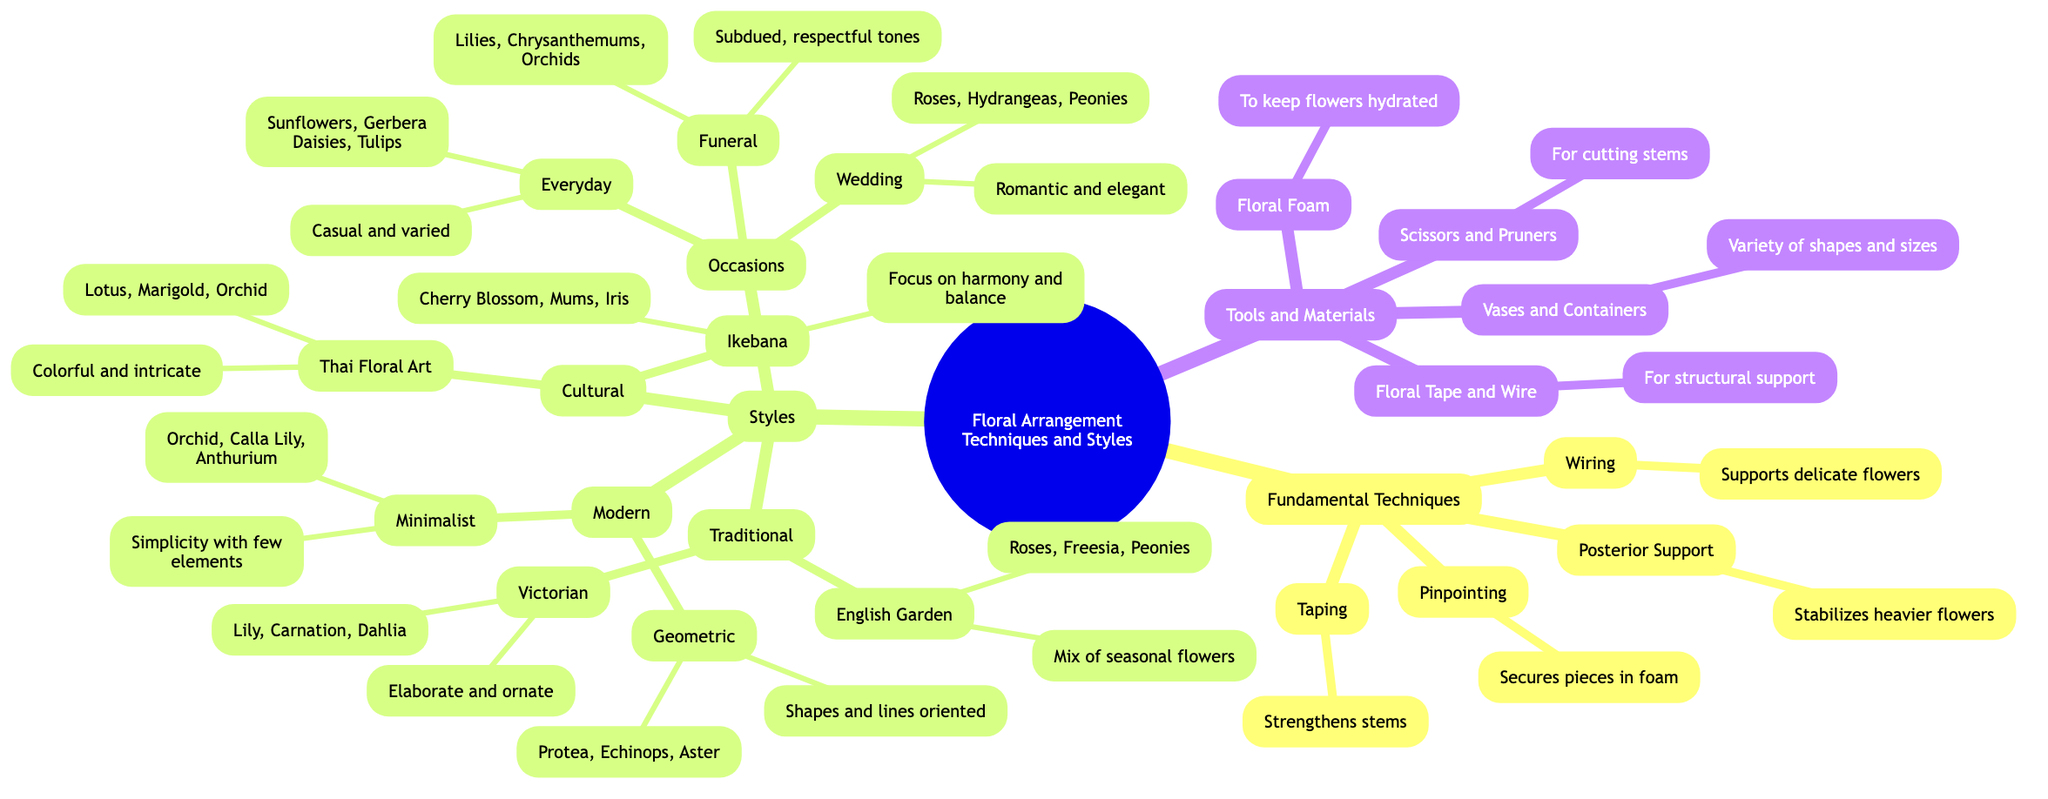What are the fundamental techniques mentioned in the diagram? The diagram lists four fundamental techniques: Wiring, Taping, Pinpointing, and Posterior Support.
Answer: Wiring, Taping, Pinpointing, Posterior Support How many styles of floral arrangements are there? The diagram categorizes styles into three main groups: Traditional, Modern, and Cultural. Each of these has different sub-styles, but the main count is three.
Answer: 3 What are the key flowers used in the Modern Minimalist style? Under the Modern category, the Minimalist style lists three key flowers: Orchid, Calla Lily, and Anthurium.
Answer: Orchid, Calla Lily, Anthurium What technique is used to stabilize heavier flowers? The technique specifically listed for stabilizing heavier flowers is called Posterior Support.
Answer: Posterior Support Which floral arrangement style focuses on harmony and balance? The Ikebana style is noted for focusing on harmony and balance, as mentioned in the Cultural category.
Answer: Ikebana Which occasion is described as "Romantic and elegant"? The Wedding occasion is described this way in the diagram under the Occasions category.
Answer: Wedding How many key flowers are listed under Thai Floral Art? The diagram states that there are three key flowers associated with Thai Floral Art: Lotus, Marigold, and Orchid.
Answer: 3 What tool is used to keep flowers hydrated? Floral Foam is the specific tool mentioned for keeping flowers hydrated in the Tools and Materials section.
Answer: Floral Foam What is the main focus of the Victorian style in floral arrangements? The Victorian style is characterized as "Elaborate and ornate," highlighting its intricate design aspects.
Answer: Elaborate and ornate 